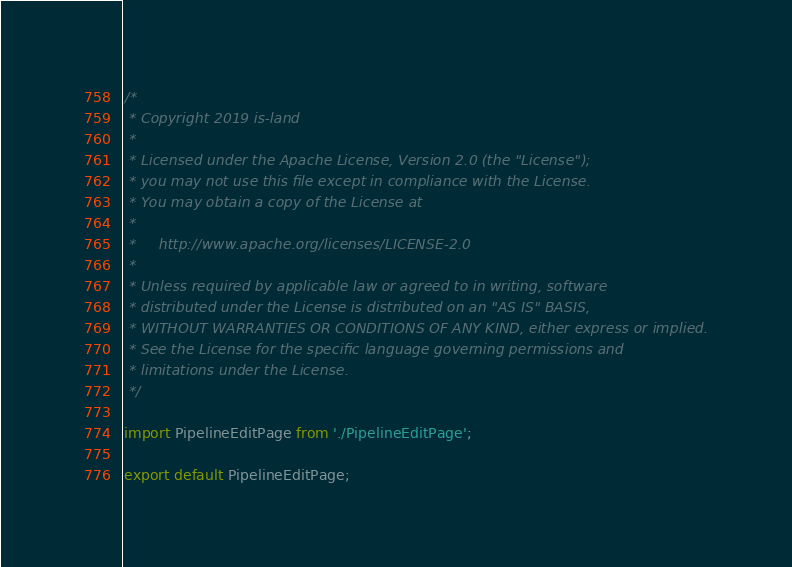Convert code to text. <code><loc_0><loc_0><loc_500><loc_500><_JavaScript_>/*
 * Copyright 2019 is-land
 *
 * Licensed under the Apache License, Version 2.0 (the "License");
 * you may not use this file except in compliance with the License.
 * You may obtain a copy of the License at
 *
 *     http://www.apache.org/licenses/LICENSE-2.0
 *
 * Unless required by applicable law or agreed to in writing, software
 * distributed under the License is distributed on an "AS IS" BASIS,
 * WITHOUT WARRANTIES OR CONDITIONS OF ANY KIND, either express or implied.
 * See the License for the specific language governing permissions and
 * limitations under the License.
 */

import PipelineEditPage from './PipelineEditPage';

export default PipelineEditPage;
</code> 